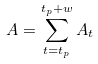<formula> <loc_0><loc_0><loc_500><loc_500>A = \sum _ { t = t _ { p } } ^ { t _ { p } + w } { A _ { t } }</formula> 